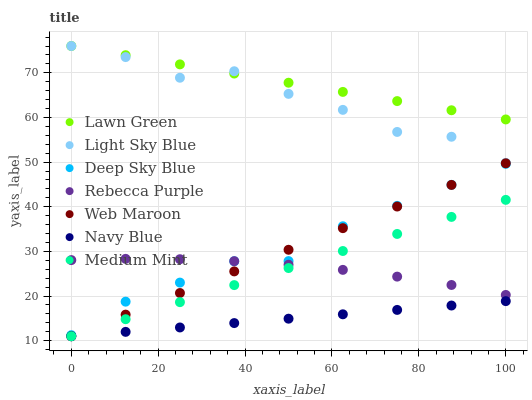Does Navy Blue have the minimum area under the curve?
Answer yes or no. Yes. Does Lawn Green have the maximum area under the curve?
Answer yes or no. Yes. Does Lawn Green have the minimum area under the curve?
Answer yes or no. No. Does Navy Blue have the maximum area under the curve?
Answer yes or no. No. Is Medium Mint the smoothest?
Answer yes or no. Yes. Is Light Sky Blue the roughest?
Answer yes or no. Yes. Is Lawn Green the smoothest?
Answer yes or no. No. Is Lawn Green the roughest?
Answer yes or no. No. Does Medium Mint have the lowest value?
Answer yes or no. Yes. Does Lawn Green have the lowest value?
Answer yes or no. No. Does Light Sky Blue have the highest value?
Answer yes or no. Yes. Does Navy Blue have the highest value?
Answer yes or no. No. Is Medium Mint less than Lawn Green?
Answer yes or no. Yes. Is Light Sky Blue greater than Medium Mint?
Answer yes or no. Yes. Does Light Sky Blue intersect Lawn Green?
Answer yes or no. Yes. Is Light Sky Blue less than Lawn Green?
Answer yes or no. No. Is Light Sky Blue greater than Lawn Green?
Answer yes or no. No. Does Medium Mint intersect Lawn Green?
Answer yes or no. No. 